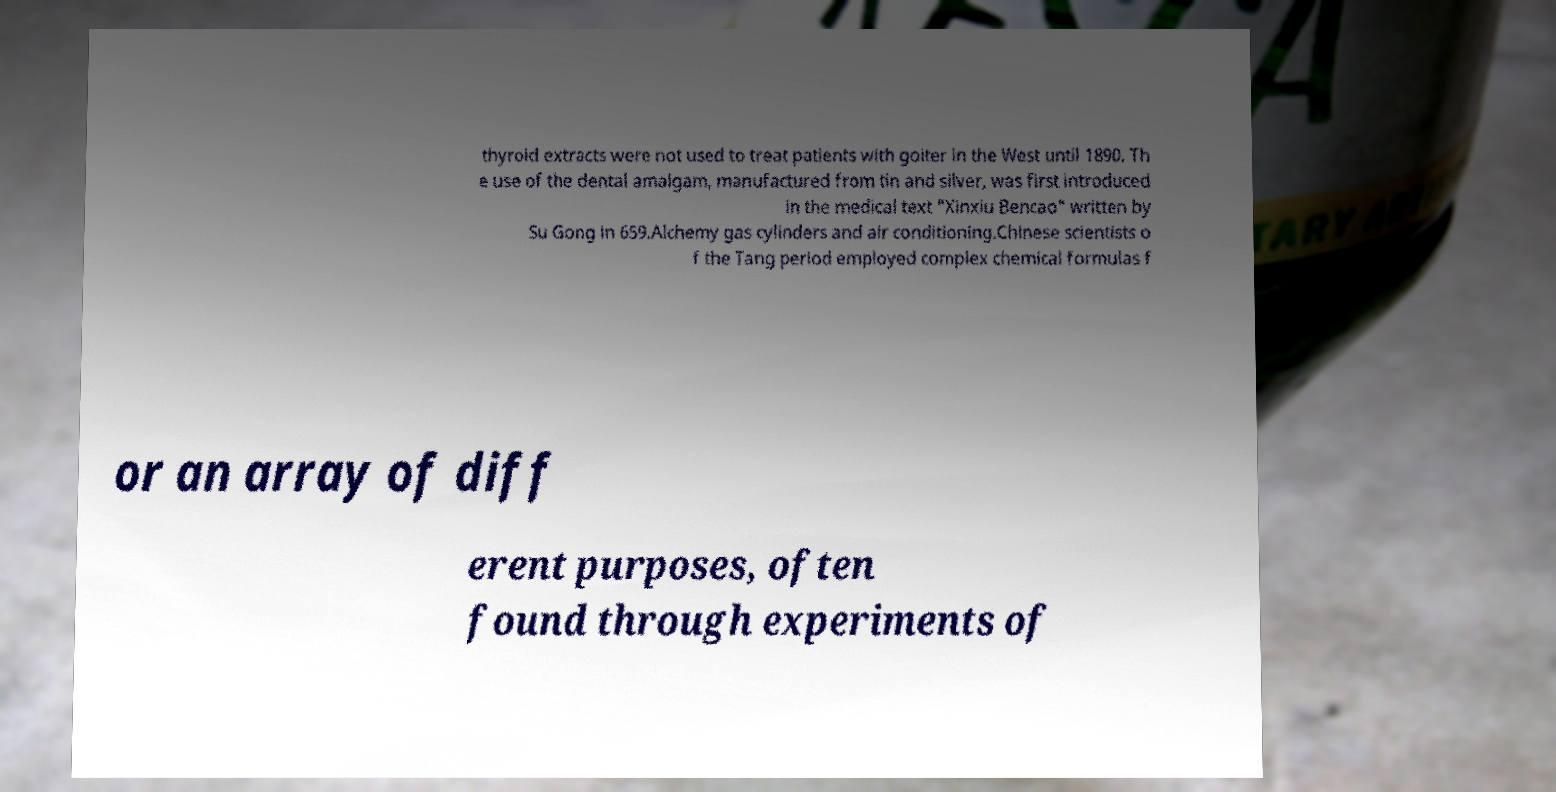Can you read and provide the text displayed in the image?This photo seems to have some interesting text. Can you extract and type it out for me? thyroid extracts were not used to treat patients with goiter in the West until 1890. Th e use of the dental amalgam, manufactured from tin and silver, was first introduced in the medical text "Xinxiu Bencao" written by Su Gong in 659.Alchemy gas cylinders and air conditioning.Chinese scientists o f the Tang period employed complex chemical formulas f or an array of diff erent purposes, often found through experiments of 